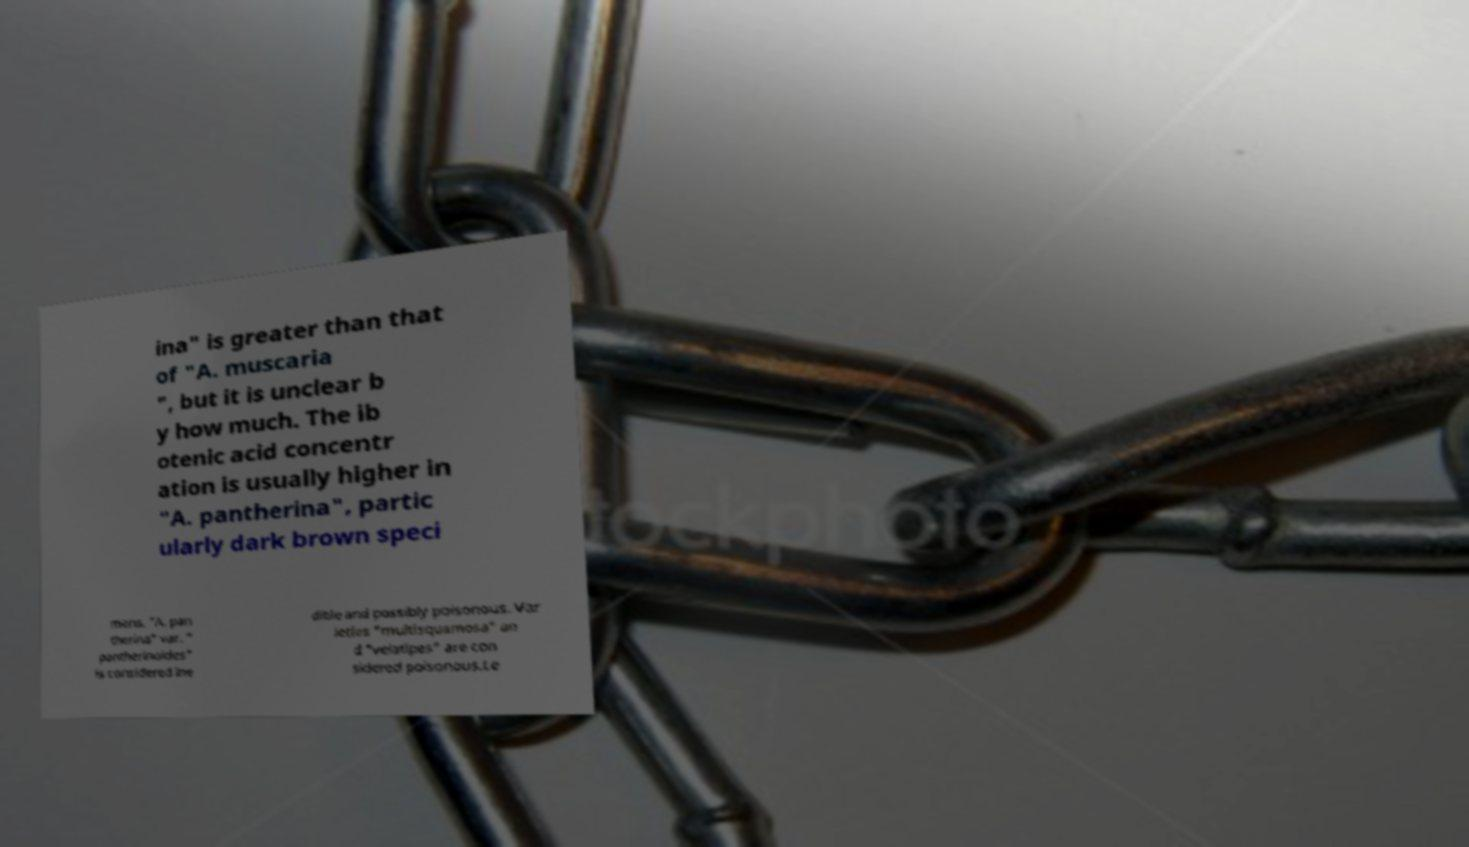Can you accurately transcribe the text from the provided image for me? ina" is greater than that of "A. muscaria ", but it is unclear b y how much. The ib otenic acid concentr ation is usually higher in "A. pantherina", partic ularly dark brown speci mens. "A. pan therina" var. " pantherinoides" is considered ine dible and possibly poisonous. Var ieties "multisquamosa" an d "velatipes" are con sidered poisonous.Le 